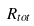Convert formula to latex. <formula><loc_0><loc_0><loc_500><loc_500>R _ { t o t }</formula> 